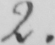What does this handwritten line say? 2 . 